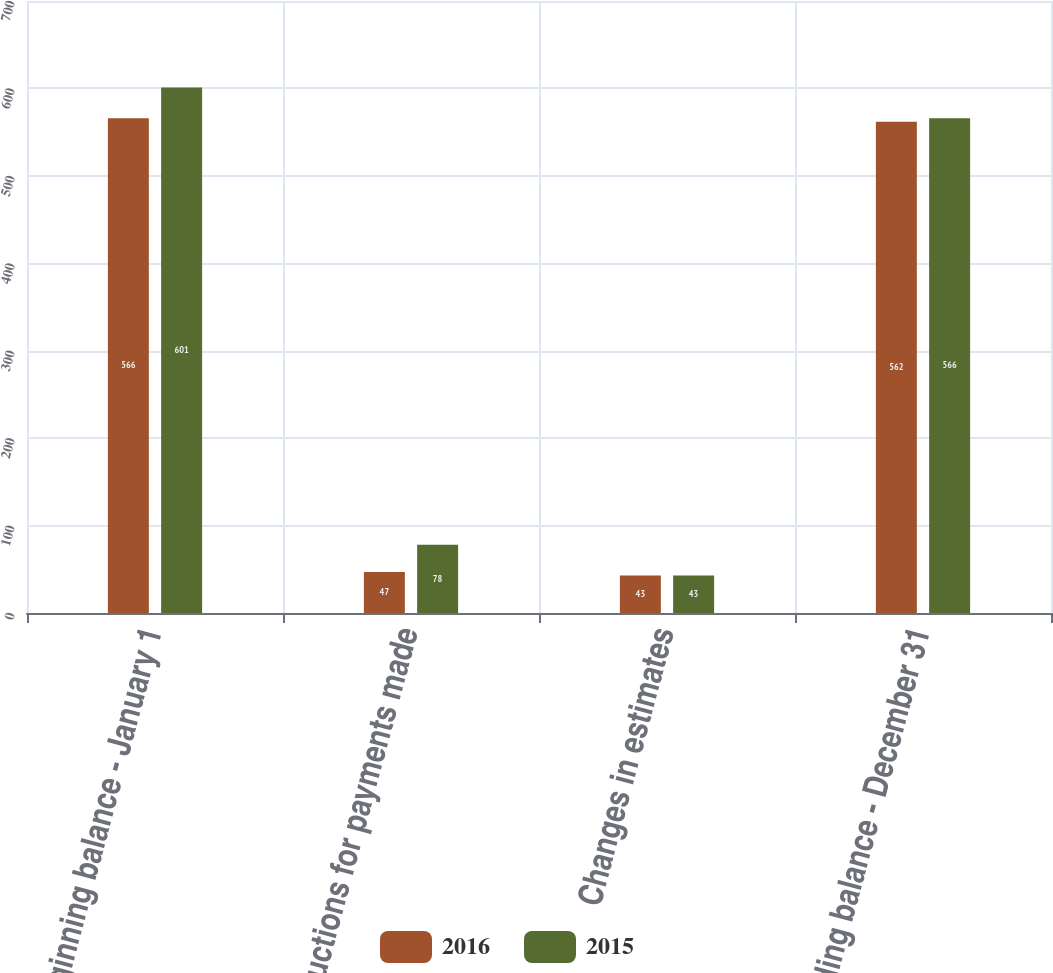<chart> <loc_0><loc_0><loc_500><loc_500><stacked_bar_chart><ecel><fcel>Beginning balance - January 1<fcel>Reductions for payments made<fcel>Changes in estimates<fcel>Ending balance - December 31<nl><fcel>2016<fcel>566<fcel>47<fcel>43<fcel>562<nl><fcel>2015<fcel>601<fcel>78<fcel>43<fcel>566<nl></chart> 